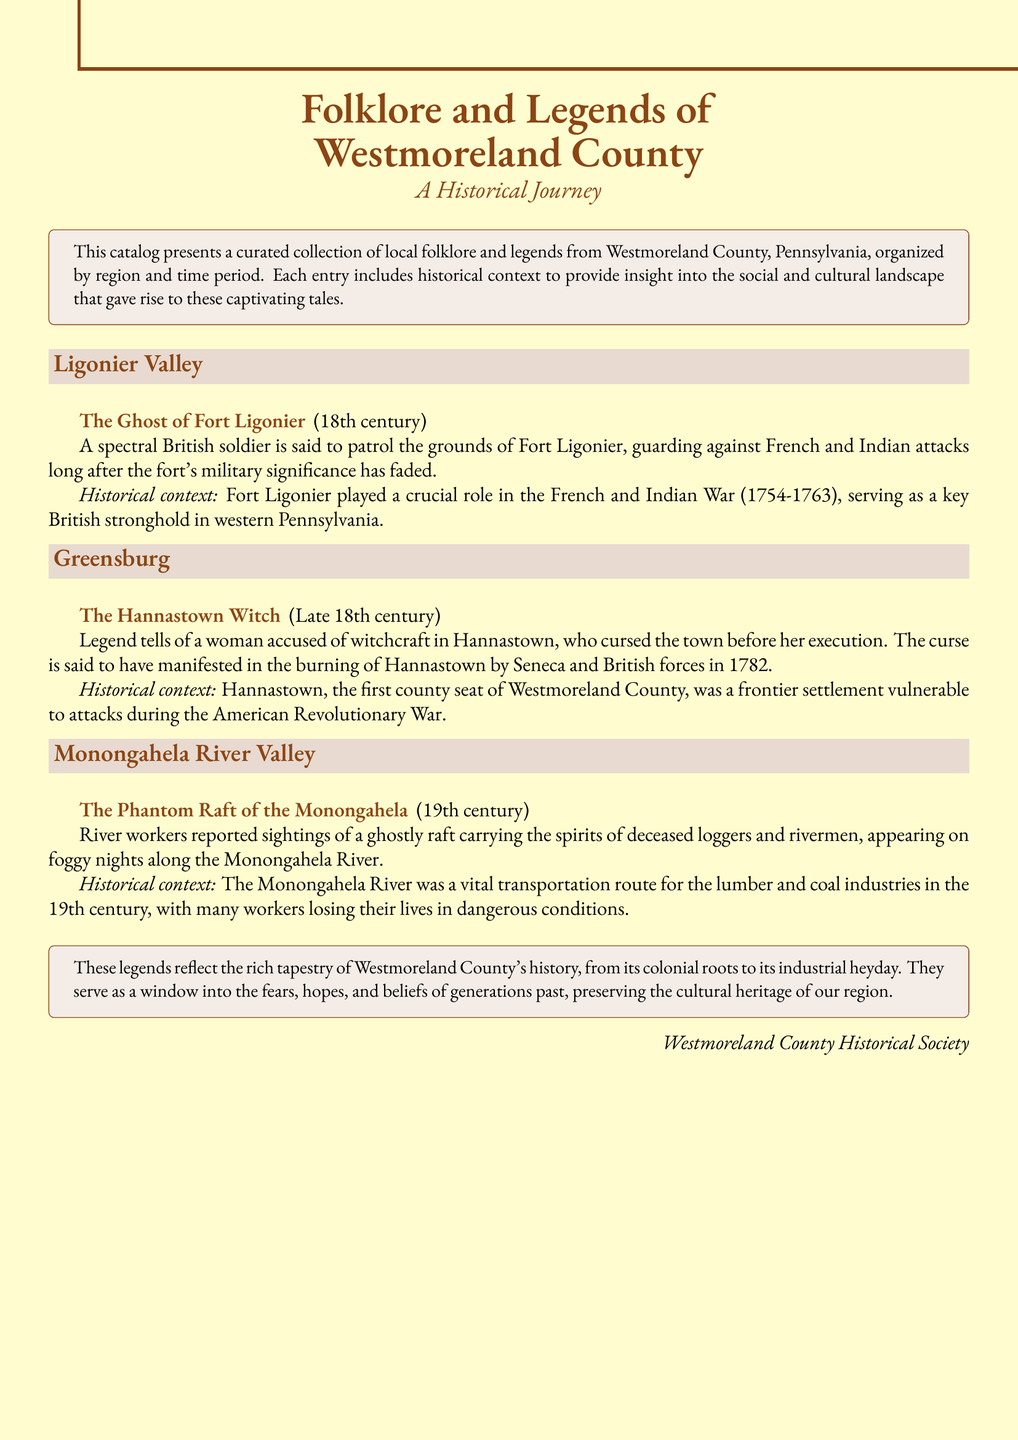What is the title of the catalog? The title of the catalog is prominently featured at the top of the document, stating "Folklore and Legends of Westmoreland County".
Answer: Folklore and Legends of Westmoreland County What is the historical context of the Ghost of Fort Ligonier? The historical context explains the significance of Fort Ligonier during the French and Indian War, highlighting its role as a British stronghold.
Answer: Crucial role in the French and Indian War In which century does the legend of The Hannastown Witch take place? The document specifies that the legend of The Hannastown Witch is from the late 18th century.
Answer: Late 18th century What type of supernatural being is involved in the legend of The Hannastown Witch? The document describes the main character in this legend as a woman accused of witchcraft.
Answer: Witch Which region is associated with the Phantom Raft of the Monongahela? The entry specifies that this legend is related to the Monongahela River Valley.
Answer: Monongahela River Valley What event is connected to the burning of Hannastown? The document explains that the burning is connected to attacks during the American Revolutionary War.
Answer: American Revolutionary War How does the document describe the cultural significance of the legends? The catalog notes that the legends reflect the rich tapestry of Westmoreland County's history and preserve the cultural heritage.
Answer: Preserve cultural heritage What aspect of historical context is provided for each entry? Each entry includes background information that gives insight into the social and cultural landscape of the time.
Answer: Social and cultural landscape 